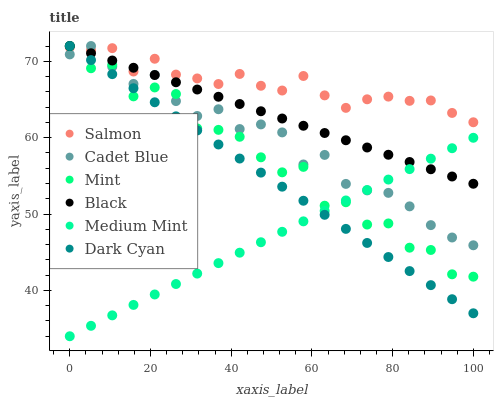Does Medium Mint have the minimum area under the curve?
Answer yes or no. Yes. Does Salmon have the maximum area under the curve?
Answer yes or no. Yes. Does Cadet Blue have the minimum area under the curve?
Answer yes or no. No. Does Cadet Blue have the maximum area under the curve?
Answer yes or no. No. Is Medium Mint the smoothest?
Answer yes or no. Yes. Is Mint the roughest?
Answer yes or no. Yes. Is Cadet Blue the smoothest?
Answer yes or no. No. Is Cadet Blue the roughest?
Answer yes or no. No. Does Medium Mint have the lowest value?
Answer yes or no. Yes. Does Cadet Blue have the lowest value?
Answer yes or no. No. Does Mint have the highest value?
Answer yes or no. Yes. Does Salmon have the highest value?
Answer yes or no. No. Is Medium Mint less than Salmon?
Answer yes or no. Yes. Is Salmon greater than Medium Mint?
Answer yes or no. Yes. Does Medium Mint intersect Dark Cyan?
Answer yes or no. Yes. Is Medium Mint less than Dark Cyan?
Answer yes or no. No. Is Medium Mint greater than Dark Cyan?
Answer yes or no. No. Does Medium Mint intersect Salmon?
Answer yes or no. No. 